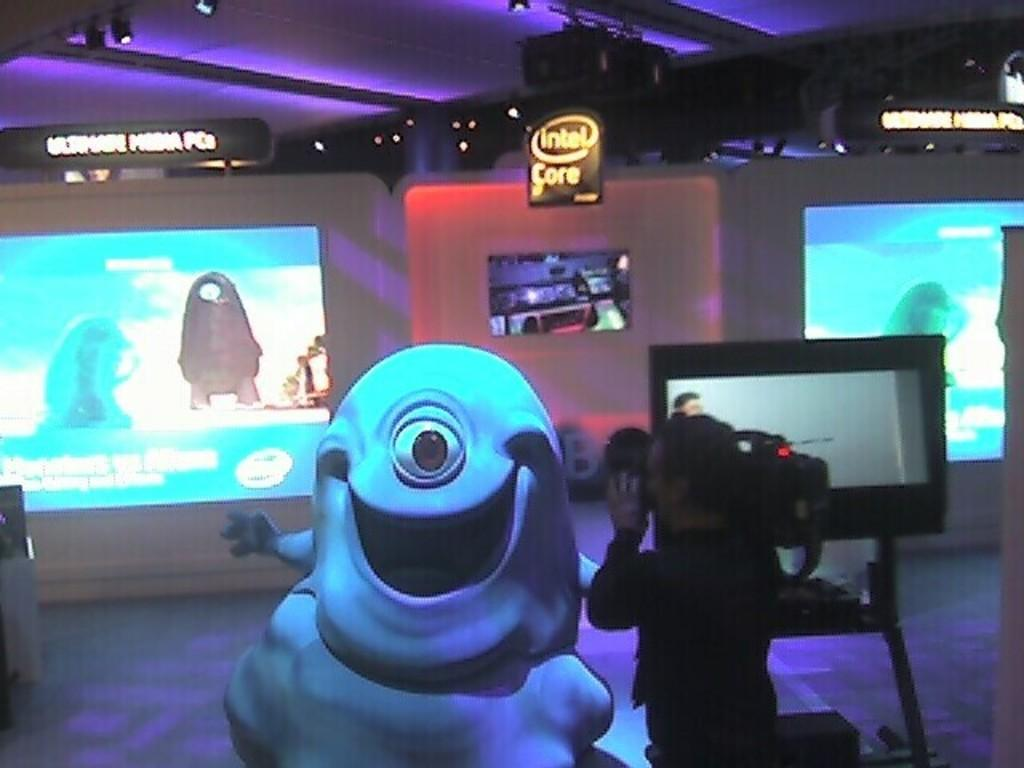Provide a one-sentence caption for the provided image. A man with a video camera taping Bob from the movie Monsters vs. Aliens. 